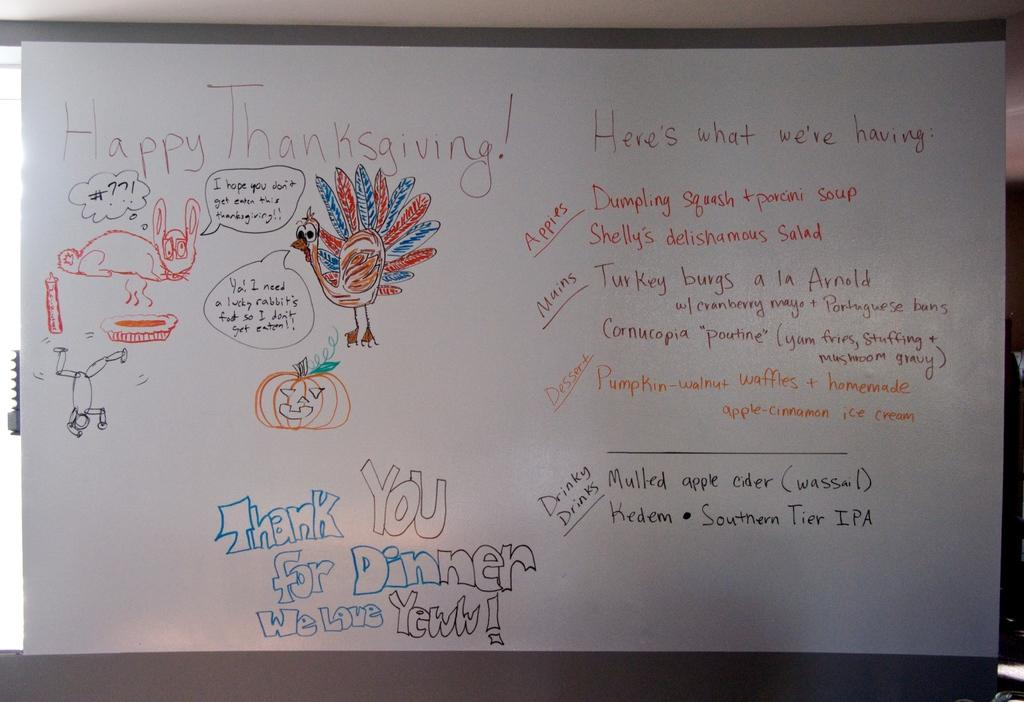<image>
Render a clear and concise summary of the photo. A white board says "Thank you for dinner, we love you!" at the bottom 